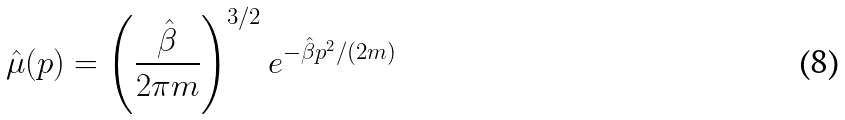Convert formula to latex. <formula><loc_0><loc_0><loc_500><loc_500>\hat { \mu } ( p ) = \left ( \frac { \hat { \beta } } { 2 \pi m } \right ) ^ { 3 / 2 } e ^ { - \hat { \beta } p ^ { 2 } / ( 2 m ) }</formula> 